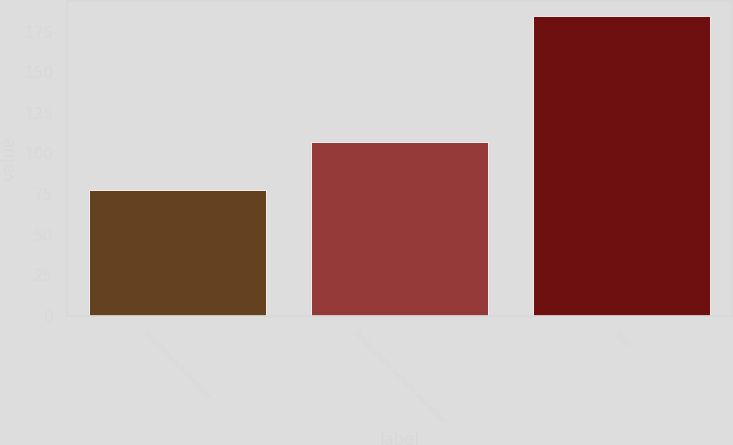Convert chart to OTSL. <chart><loc_0><loc_0><loc_500><loc_500><bar_chart><fcel>Maintenance revenue<fcel>Professional service and other<fcel>Total<nl><fcel>77.6<fcel>107.2<fcel>184.8<nl></chart> 